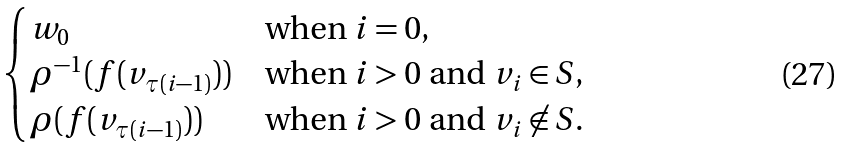Convert formula to latex. <formula><loc_0><loc_0><loc_500><loc_500>\begin{cases} w _ { 0 } & \text {when $i = 0$,} \\ \rho ^ { - 1 } ( f ( v _ { \tau ( i - 1 ) } ) ) & \text {when $i > 0$ and $v_{i} \in S$,} \\ \rho ( f ( v _ { \tau ( i - 1 ) } ) ) & \text {when $i > 0$ and $v_{i} \not\in S$.} \\ \end{cases}</formula> 